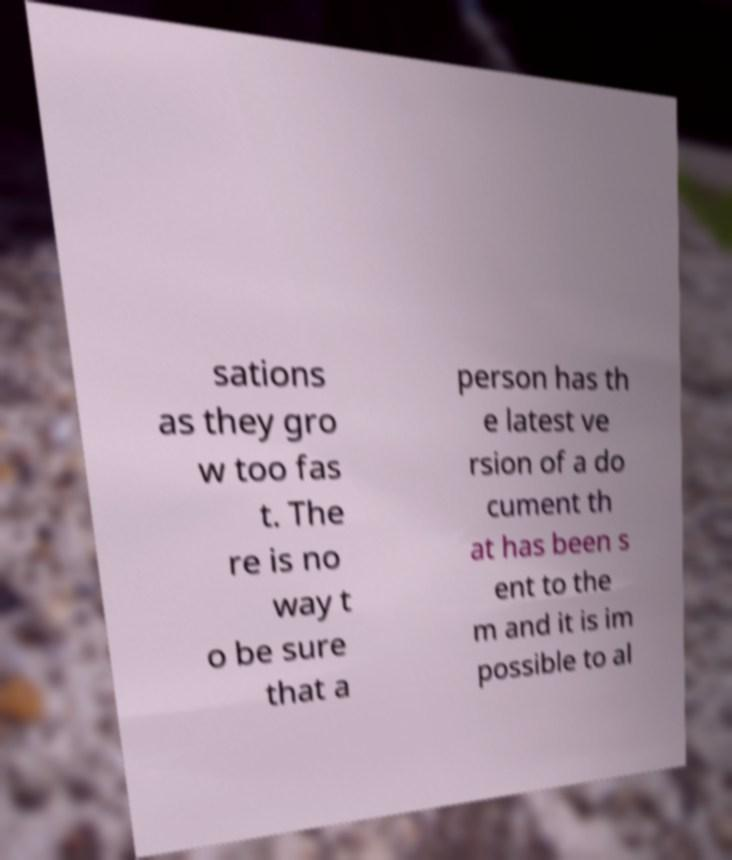There's text embedded in this image that I need extracted. Can you transcribe it verbatim? sations as they gro w too fas t. The re is no way t o be sure that a person has th e latest ve rsion of a do cument th at has been s ent to the m and it is im possible to al 